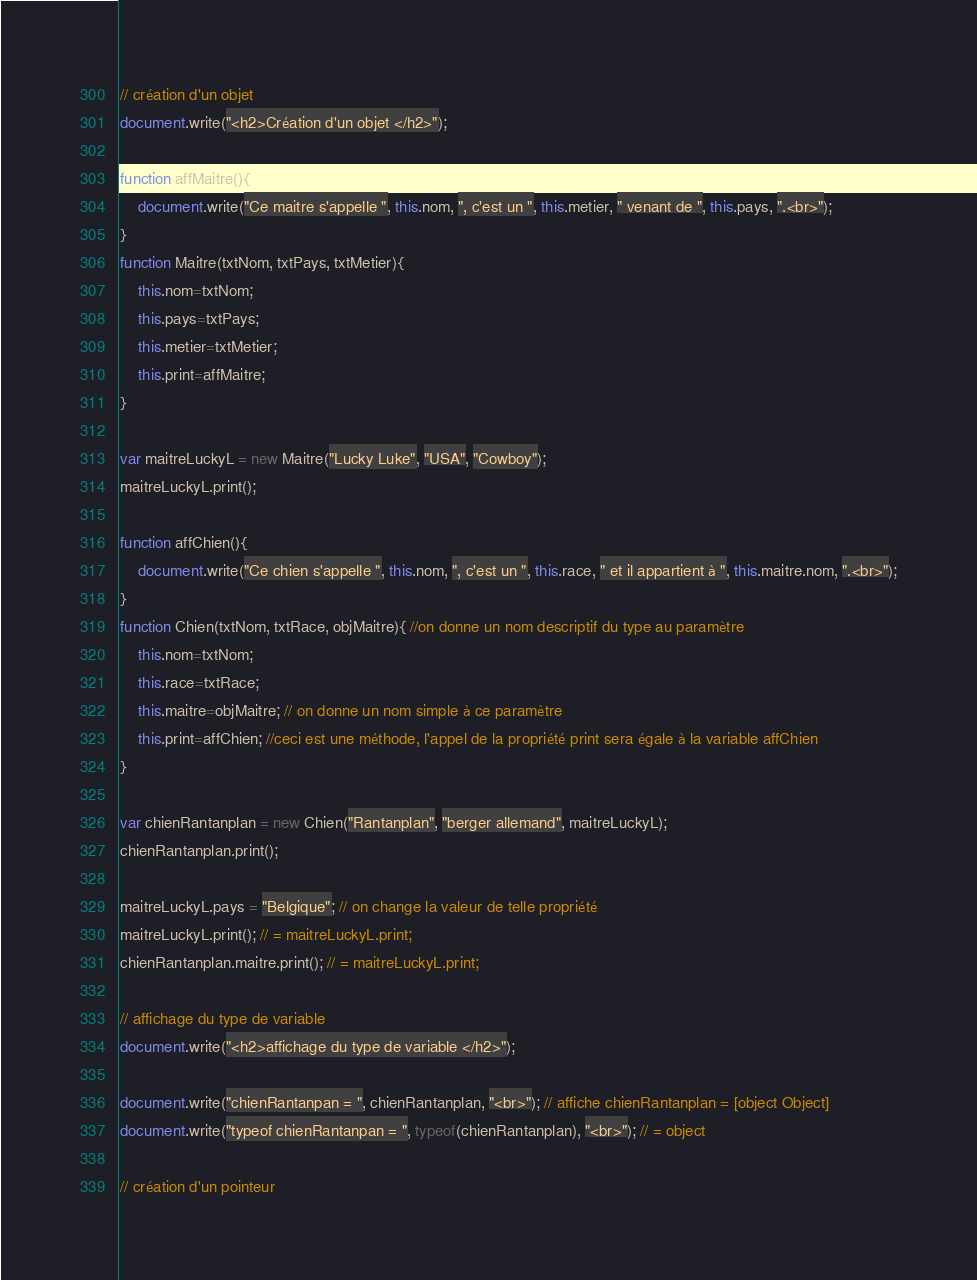<code> <loc_0><loc_0><loc_500><loc_500><_JavaScript_>
// création d'un objet
document.write("<h2>Création d'un objet </h2>");

function affMaitre(){
    document.write("Ce maitre s'appelle ", this.nom, ", c'est un ", this.metier, " venant de ", this.pays, ".<br>");
}
function Maitre(txtNom, txtPays, txtMetier){
    this.nom=txtNom;
    this.pays=txtPays; 
    this.metier=txtMetier; 
    this.print=affMaitre;
}

var maitreLuckyL = new Maitre("Lucky Luke", "USA", "Cowboy");
maitreLuckyL.print();

function affChien(){
    document.write("Ce chien s'appelle ", this.nom, ", c'est un ", this.race, " et il appartient à ", this.maitre.nom, ".<br>");
}
function Chien(txtNom, txtRace, objMaitre){ //on donne un nom descriptif du type au paramètre
    this.nom=txtNom;
    this.race=txtRace;
    this.maitre=objMaitre; // on donne un nom simple à ce paramètre
    this.print=affChien; //ceci est une méthode, l'appel de la propriété print sera égale à la variable affChien
}

var chienRantanplan = new Chien("Rantanplan", "berger allemand", maitreLuckyL);
chienRantanplan.print();

maitreLuckyL.pays = "Belgique"; // on change la valeur de telle propriété
maitreLuckyL.print(); // = maitreLuckyL.print;
chienRantanplan.maitre.print(); // = maitreLuckyL.print;

// affichage du type de variable
document.write("<h2>affichage du type de variable </h2>");

document.write("chienRantanpan = ", chienRantanplan, "<br>"); // affiche chienRantanplan = [object Object]
document.write("typeof chienRantanpan = ", typeof(chienRantanplan), "<br>"); // = object

// création d'un pointeur</code> 